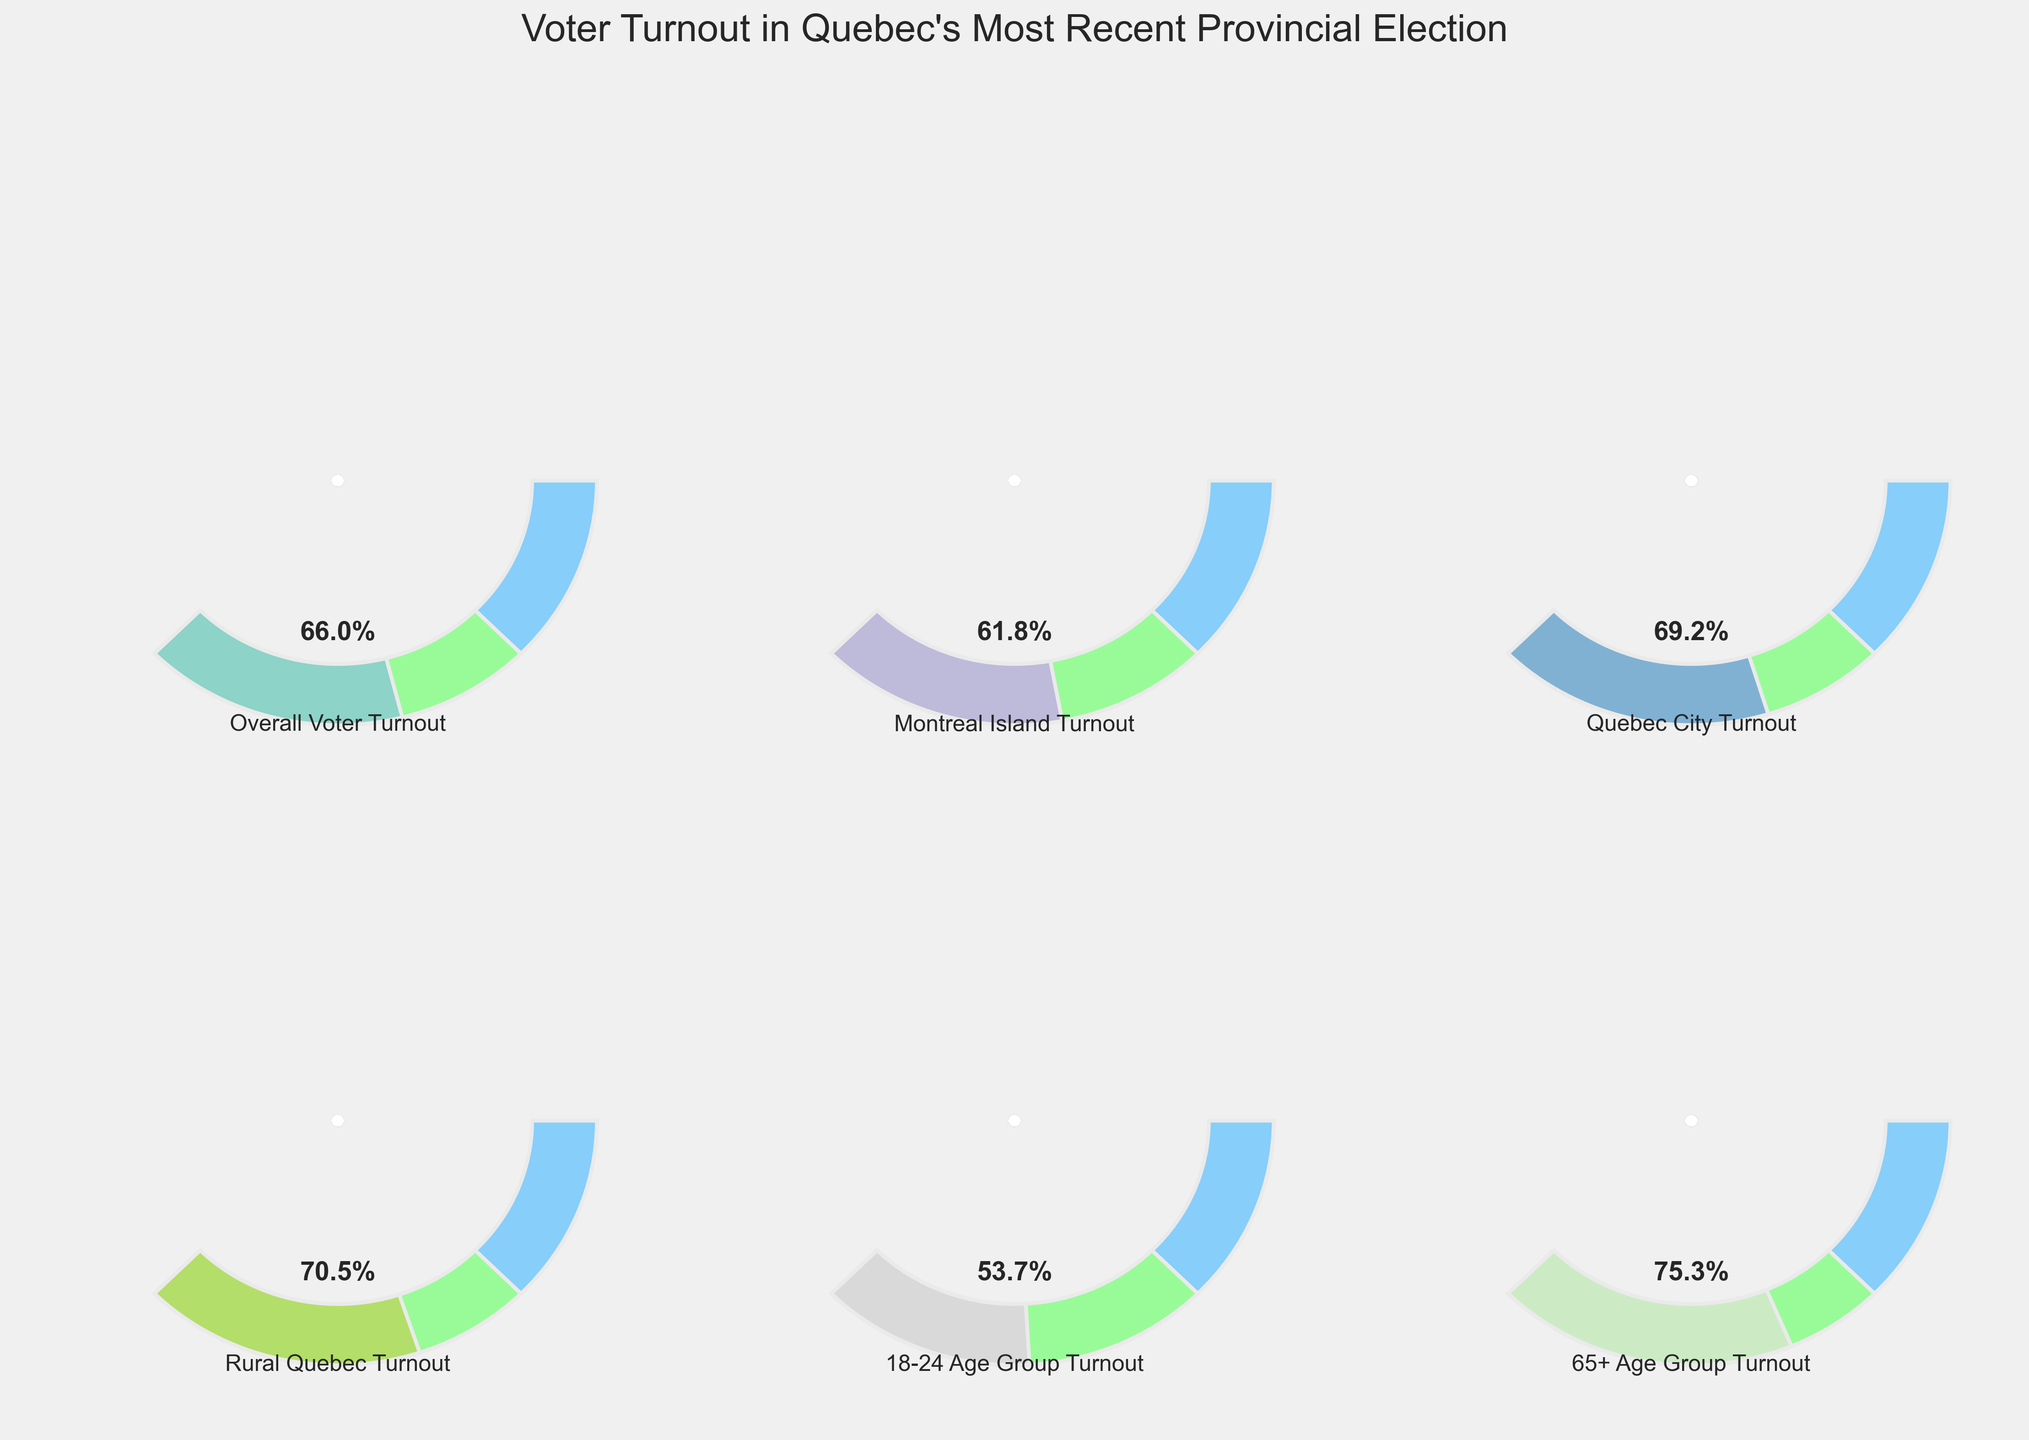What's the voter turnout for the "Overall Voter Turnout" category? Locate the gauge labeled "Overall Voter Turnout" and read the value displayed in the center.
Answer: 66.05% Which category has the highest voter turnout? Identify the gauge with the highest percentage value displayed. Among the six gauges, find the one with the highest number.
Answer: 65+ Age Group Turnout How much higher is the "Rural Quebec Turnout" compared to the "Montreal Island Turnout"? Find the values for both "Rural Quebec Turnout" and "Montreal Island Turnout". Subtract the "Montreal Island Turnout" value from the "Rural Quebec Turnout" value (70.5% - 61.8%).
Answer: 8.7% What is the average voter turnout across all categories? Add the turnout values for all categories (66.05 + 61.8 + 69.2 + 70.5 + 53.7 + 75.3) and divide by the number of categories (6).
Answer: 66.76% Which region has a lower voter turnout: "Montreal Island" or "Quebec City"? Compare the values for "Montreal Island Turnout" and "Quebec City Turnout". The lower value indicates the region with lower turnout.
Answer: Montreal Island Is the voter turnout for the "18-24 Age Group" above 50%? Look at the gauge for the "18-24 Age Group Turnout" and check if the displayed value is higher than 50%.
Answer: Yes What is the title of the figure? Look at the top of the figure and read the title displayed there.
Answer: Voter Turnout in Quebec's Most Recent Provincial Election How does the voter turnout for the "65+ Age Group" compare to the "Overall Voter Turnout"? Compare the values for "65+ Age Group Turnout" and "Overall Voter Turnout". Determine if the "65+ Age Group Turnout" is higher, lower, or equal to the "Overall Voter Turnout".
Answer: Higher 